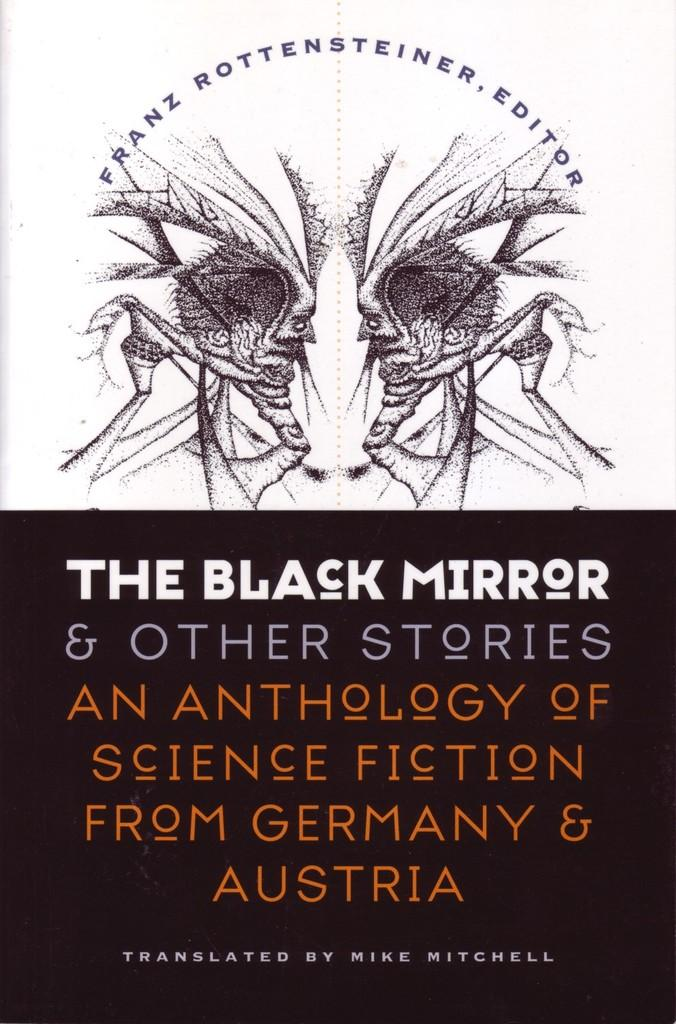What is present in the picture? There is a poster in the picture. What can be found on the poster? The poster contains text and images. Where is the person sitting at the desk in the image? There is no person or desk present in the image; it only features a poster with text and images. What is the message of the good-bye note on the poster? There is no good-bye note present on the poster; it only contains text and images. 